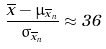Convert formula to latex. <formula><loc_0><loc_0><loc_500><loc_500>\frac { \overline { x } - \mu _ { \overline { x } _ { n } } } { \sigma _ { \overline { x } _ { n } } } \approx 3 6</formula> 